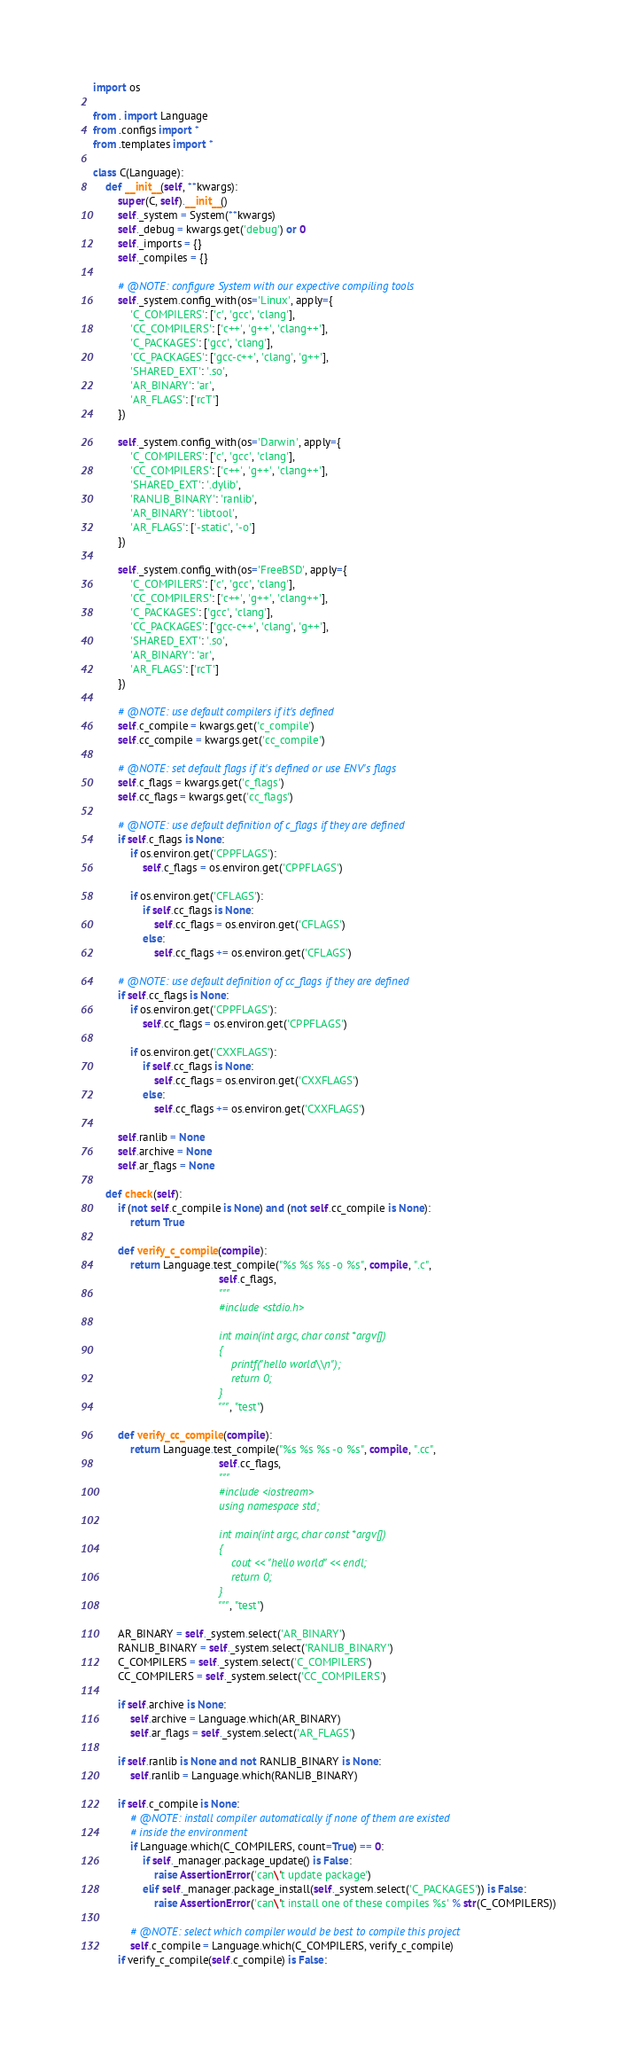Convert code to text. <code><loc_0><loc_0><loc_500><loc_500><_Python_>import os

from . import Language
from .configs import *
from .templates import *

class C(Language):
    def __init__(self, **kwargs):
        super(C, self).__init__()
        self._system = System(**kwargs)
        self._debug = kwargs.get('debug') or 0
        self._imports = {}
        self._compiles = {}

        # @NOTE: configure System with our expective compiling tools
        self._system.config_with(os='Linux', apply={
            'C_COMPILERS': ['c', 'gcc', 'clang'],
            'CC_COMPILERS': ['c++', 'g++', 'clang++'],
            'C_PACKAGES': ['gcc', 'clang'],
            'CC_PACKAGES': ['gcc-c++', 'clang', 'g++'],
            'SHARED_EXT': '.so',
            'AR_BINARY': 'ar',
            'AR_FLAGS': ['rcT']
        })

        self._system.config_with(os='Darwin', apply={
            'C_COMPILERS': ['c', 'gcc', 'clang'],
            'CC_COMPILERS': ['c++', 'g++', 'clang++'],
            'SHARED_EXT': '.dylib',
            'RANLIB_BINARY': 'ranlib',
            'AR_BINARY': 'libtool',
            'AR_FLAGS': ['-static', '-o']
        })

        self._system.config_with(os='FreeBSD', apply={
            'C_COMPILERS': ['c', 'gcc', 'clang'],
            'CC_COMPILERS': ['c++', 'g++', 'clang++'],
            'C_PACKAGES': ['gcc', 'clang'],
            'CC_PACKAGES': ['gcc-c++', 'clang', 'g++'],
            'SHARED_EXT': '.so',
            'AR_BINARY': 'ar',
            'AR_FLAGS': ['rcT']
        })

        # @NOTE: use default compilers if it's defined
        self.c_compile = kwargs.get('c_compile')
        self.cc_compile = kwargs.get('cc_compile')

        # @NOTE: set default flags if it's defined or use ENV's flags
        self.c_flags = kwargs.get('c_flags')
        self.cc_flags = kwargs.get('cc_flags')

        # @NOTE: use default definition of c_flags if they are defined
        if self.c_flags is None:
            if os.environ.get('CPPFLAGS'):
                self.c_flags = os.environ.get('CPPFLAGS')

            if os.environ.get('CFLAGS'):
                if self.cc_flags is None:
                    self.cc_flags = os.environ.get('CFLAGS')
                else:
                    self.cc_flags += os.environ.get('CFLAGS')

        # @NOTE: use default definition of cc_flags if they are defined
        if self.cc_flags is None:
            if os.environ.get('CPPFLAGS'):
                self.cc_flags = os.environ.get('CPPFLAGS')

            if os.environ.get('CXXFLAGS'):
                if self.cc_flags is None:
                    self.cc_flags = os.environ.get('CXXFLAGS')
                else:
                    self.cc_flags += os.environ.get('CXXFLAGS')

        self.ranlib = None
        self.archive = None
        self.ar_flags = None

    def check(self):
        if (not self.c_compile is None) and (not self.cc_compile is None):
            return True

        def verify_c_compile(compile):
            return Language.test_compile("%s %s %s -o %s", compile, ".c",
                                         self.c_flags,
                                         """
                                         #include <stdio.h>

                                         int main(int argc, char const *argv[])
                                         {
                                             printf("hello world\\n");
                                             return 0;
                                         }
                                         """, "test")

        def verify_cc_compile(compile):
            return Language.test_compile("%s %s %s -o %s", compile, ".cc",
                                         self.cc_flags,
                                         """
                                         #include <iostream>
                                         using namespace std;

                                         int main(int argc, char const *argv[])
                                         {
                                             cout << "hello world" << endl;
                                             return 0;
                                         }
                                         """, "test")

        AR_BINARY = self._system.select('AR_BINARY')
        RANLIB_BINARY = self._system.select('RANLIB_BINARY')
        C_COMPILERS = self._system.select('C_COMPILERS')
        CC_COMPILERS = self._system.select('CC_COMPILERS')

        if self.archive is None:
            self.archive = Language.which(AR_BINARY)
            self.ar_flags = self._system.select('AR_FLAGS')

        if self.ranlib is None and not RANLIB_BINARY is None:
            self.ranlib = Language.which(RANLIB_BINARY)

        if self.c_compile is None:
            # @NOTE: install compiler automatically if none of them are existed
            # inside the environment
            if Language.which(C_COMPILERS, count=True) == 0:
                if self._manager.package_update() is False:
                    raise AssertionError('can\'t update package')
                elif self._manager.package_install(self._system.select('C_PACKAGES')) is False:
                    raise AssertionError('can\'t install one of these compiles %s' % str(C_COMPILERS))

            # @NOTE: select which compiler would be best to compile this project
            self.c_compile = Language.which(C_COMPILERS, verify_c_compile)
        if verify_c_compile(self.c_compile) is False:</code> 